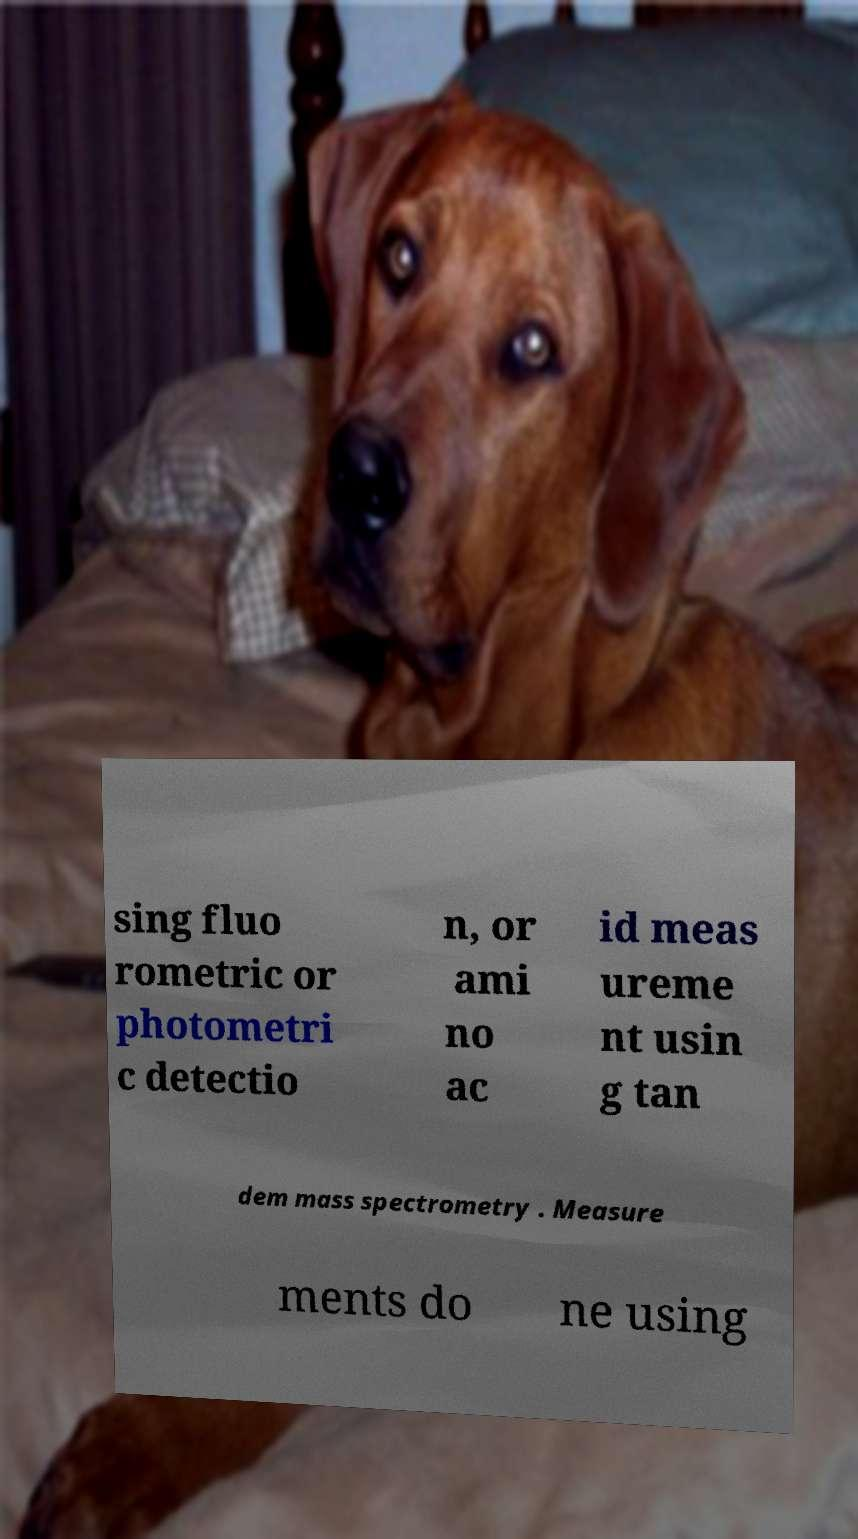For documentation purposes, I need the text within this image transcribed. Could you provide that? sing fluo rometric or photometri c detectio n, or ami no ac id meas ureme nt usin g tan dem mass spectrometry . Measure ments do ne using 